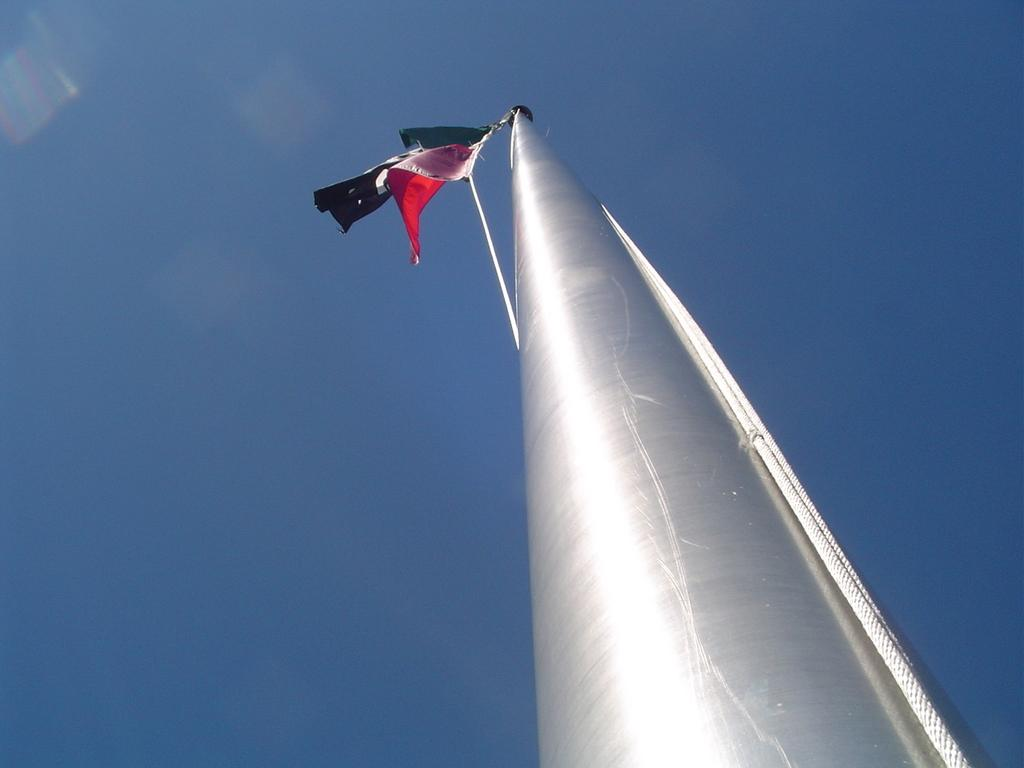What is located in the foreground of the image? There is a pole in the foreground of the image. What is attached to the pole? There is a flag attached to the pole. What can be seen in the background of the image? The sky is visible in the background of the image. What type of thrill can be experienced while observing the zephyr in the image? There is no mention of a zephyr or any thrill-inducing element in the image. 